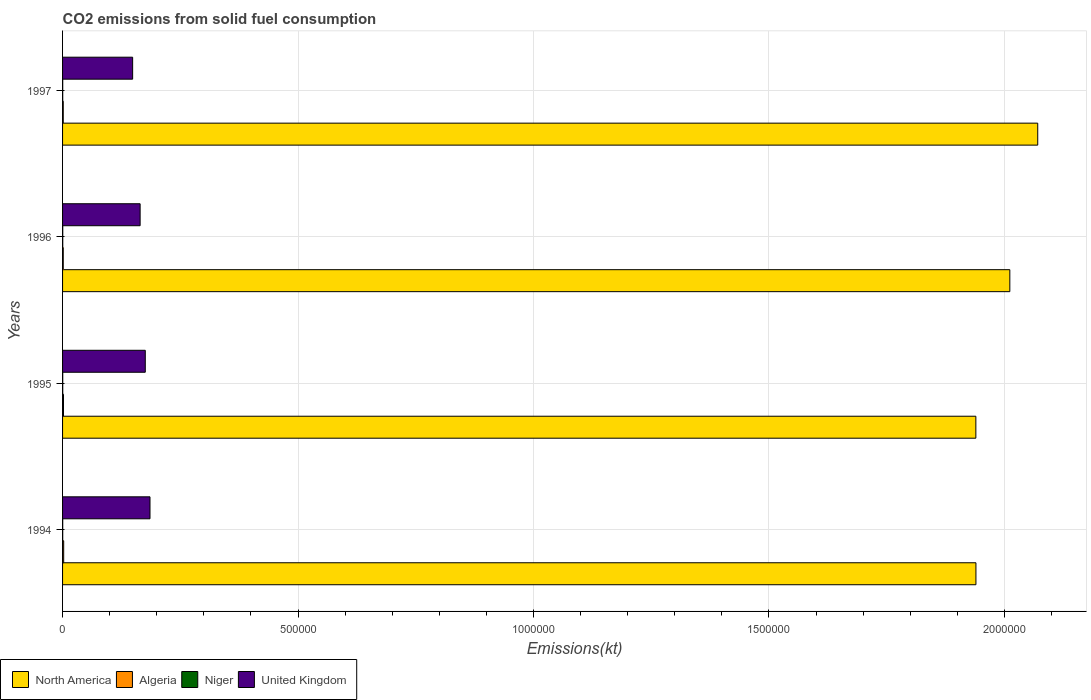How many different coloured bars are there?
Your answer should be very brief. 4. How many bars are there on the 3rd tick from the top?
Make the answer very short. 4. In how many cases, is the number of bars for a given year not equal to the number of legend labels?
Offer a very short reply. 0. What is the amount of CO2 emitted in United Kingdom in 1994?
Make the answer very short. 1.86e+05. Across all years, what is the maximum amount of CO2 emitted in United Kingdom?
Offer a terse response. 1.86e+05. Across all years, what is the minimum amount of CO2 emitted in North America?
Your response must be concise. 1.94e+06. In which year was the amount of CO2 emitted in Algeria minimum?
Offer a terse response. 1997. What is the total amount of CO2 emitted in Niger in the graph?
Give a very brief answer. 1400.79. What is the difference between the amount of CO2 emitted in Niger in 1994 and that in 1995?
Your answer should be compact. -29.34. What is the difference between the amount of CO2 emitted in North America in 1994 and the amount of CO2 emitted in Algeria in 1995?
Give a very brief answer. 1.94e+06. What is the average amount of CO2 emitted in North America per year?
Ensure brevity in your answer.  1.99e+06. In the year 1995, what is the difference between the amount of CO2 emitted in Algeria and amount of CO2 emitted in United Kingdom?
Make the answer very short. -1.74e+05. What is the ratio of the amount of CO2 emitted in United Kingdom in 1994 to that in 1995?
Keep it short and to the point. 1.06. What is the difference between the highest and the second highest amount of CO2 emitted in Niger?
Keep it short and to the point. 22. What is the difference between the highest and the lowest amount of CO2 emitted in Algeria?
Give a very brief answer. 931.42. In how many years, is the amount of CO2 emitted in Algeria greater than the average amount of CO2 emitted in Algeria taken over all years?
Give a very brief answer. 2. Is the sum of the amount of CO2 emitted in Algeria in 1995 and 1996 greater than the maximum amount of CO2 emitted in Niger across all years?
Your answer should be compact. Yes. What does the 2nd bar from the bottom in 1994 represents?
Offer a very short reply. Algeria. How many bars are there?
Ensure brevity in your answer.  16. Are all the bars in the graph horizontal?
Give a very brief answer. Yes. Are the values on the major ticks of X-axis written in scientific E-notation?
Keep it short and to the point. No. Does the graph contain any zero values?
Give a very brief answer. No. Does the graph contain grids?
Keep it short and to the point. Yes. Where does the legend appear in the graph?
Make the answer very short. Bottom left. How are the legend labels stacked?
Keep it short and to the point. Horizontal. What is the title of the graph?
Your answer should be very brief. CO2 emissions from solid fuel consumption. Does "El Salvador" appear as one of the legend labels in the graph?
Keep it short and to the point. No. What is the label or title of the X-axis?
Your answer should be compact. Emissions(kt). What is the label or title of the Y-axis?
Offer a very short reply. Years. What is the Emissions(kt) of North America in 1994?
Offer a terse response. 1.94e+06. What is the Emissions(kt) in Algeria in 1994?
Your answer should be very brief. 2368.88. What is the Emissions(kt) in Niger in 1994?
Ensure brevity in your answer.  326.36. What is the Emissions(kt) of United Kingdom in 1994?
Offer a terse response. 1.86e+05. What is the Emissions(kt) in North America in 1995?
Your answer should be very brief. 1.94e+06. What is the Emissions(kt) in Algeria in 1995?
Offer a terse response. 1987.51. What is the Emissions(kt) in Niger in 1995?
Provide a succinct answer. 355.7. What is the Emissions(kt) in United Kingdom in 1995?
Give a very brief answer. 1.76e+05. What is the Emissions(kt) of North America in 1996?
Ensure brevity in your answer.  2.01e+06. What is the Emissions(kt) of Algeria in 1996?
Offer a terse response. 1441.13. What is the Emissions(kt) in Niger in 1996?
Offer a very short reply. 377.7. What is the Emissions(kt) in United Kingdom in 1996?
Your response must be concise. 1.65e+05. What is the Emissions(kt) in North America in 1997?
Provide a succinct answer. 2.07e+06. What is the Emissions(kt) of Algeria in 1997?
Keep it short and to the point. 1437.46. What is the Emissions(kt) of Niger in 1997?
Keep it short and to the point. 341.03. What is the Emissions(kt) of United Kingdom in 1997?
Offer a terse response. 1.49e+05. Across all years, what is the maximum Emissions(kt) of North America?
Make the answer very short. 2.07e+06. Across all years, what is the maximum Emissions(kt) of Algeria?
Offer a terse response. 2368.88. Across all years, what is the maximum Emissions(kt) of Niger?
Offer a terse response. 377.7. Across all years, what is the maximum Emissions(kt) in United Kingdom?
Make the answer very short. 1.86e+05. Across all years, what is the minimum Emissions(kt) in North America?
Provide a succinct answer. 1.94e+06. Across all years, what is the minimum Emissions(kt) of Algeria?
Offer a terse response. 1437.46. Across all years, what is the minimum Emissions(kt) in Niger?
Your answer should be compact. 326.36. Across all years, what is the minimum Emissions(kt) in United Kingdom?
Your answer should be compact. 1.49e+05. What is the total Emissions(kt) of North America in the graph?
Give a very brief answer. 7.96e+06. What is the total Emissions(kt) in Algeria in the graph?
Offer a terse response. 7234.99. What is the total Emissions(kt) in Niger in the graph?
Your answer should be compact. 1400.79. What is the total Emissions(kt) of United Kingdom in the graph?
Your answer should be compact. 6.75e+05. What is the difference between the Emissions(kt) in North America in 1994 and that in 1995?
Keep it short and to the point. 176.09. What is the difference between the Emissions(kt) in Algeria in 1994 and that in 1995?
Give a very brief answer. 381.37. What is the difference between the Emissions(kt) of Niger in 1994 and that in 1995?
Offer a very short reply. -29.34. What is the difference between the Emissions(kt) in United Kingdom in 1994 and that in 1995?
Your answer should be compact. 1.00e+04. What is the difference between the Emissions(kt) in North America in 1994 and that in 1996?
Provide a short and direct response. -7.20e+04. What is the difference between the Emissions(kt) in Algeria in 1994 and that in 1996?
Offer a very short reply. 927.75. What is the difference between the Emissions(kt) of Niger in 1994 and that in 1996?
Make the answer very short. -51.34. What is the difference between the Emissions(kt) in United Kingdom in 1994 and that in 1996?
Make the answer very short. 2.09e+04. What is the difference between the Emissions(kt) in North America in 1994 and that in 1997?
Your answer should be compact. -1.31e+05. What is the difference between the Emissions(kt) of Algeria in 1994 and that in 1997?
Keep it short and to the point. 931.42. What is the difference between the Emissions(kt) of Niger in 1994 and that in 1997?
Your response must be concise. -14.67. What is the difference between the Emissions(kt) of United Kingdom in 1994 and that in 1997?
Provide a succinct answer. 3.68e+04. What is the difference between the Emissions(kt) in North America in 1995 and that in 1996?
Your answer should be compact. -7.21e+04. What is the difference between the Emissions(kt) in Algeria in 1995 and that in 1996?
Ensure brevity in your answer.  546.38. What is the difference between the Emissions(kt) in Niger in 1995 and that in 1996?
Your answer should be compact. -22. What is the difference between the Emissions(kt) in United Kingdom in 1995 and that in 1996?
Give a very brief answer. 1.09e+04. What is the difference between the Emissions(kt) in North America in 1995 and that in 1997?
Provide a short and direct response. -1.31e+05. What is the difference between the Emissions(kt) of Algeria in 1995 and that in 1997?
Your answer should be compact. 550.05. What is the difference between the Emissions(kt) of Niger in 1995 and that in 1997?
Give a very brief answer. 14.67. What is the difference between the Emissions(kt) in United Kingdom in 1995 and that in 1997?
Provide a succinct answer. 2.68e+04. What is the difference between the Emissions(kt) in North America in 1996 and that in 1997?
Offer a very short reply. -5.93e+04. What is the difference between the Emissions(kt) in Algeria in 1996 and that in 1997?
Offer a terse response. 3.67. What is the difference between the Emissions(kt) of Niger in 1996 and that in 1997?
Keep it short and to the point. 36.67. What is the difference between the Emissions(kt) of United Kingdom in 1996 and that in 1997?
Give a very brief answer. 1.59e+04. What is the difference between the Emissions(kt) of North America in 1994 and the Emissions(kt) of Algeria in 1995?
Make the answer very short. 1.94e+06. What is the difference between the Emissions(kt) in North America in 1994 and the Emissions(kt) in Niger in 1995?
Your answer should be very brief. 1.94e+06. What is the difference between the Emissions(kt) of North America in 1994 and the Emissions(kt) of United Kingdom in 1995?
Give a very brief answer. 1.76e+06. What is the difference between the Emissions(kt) of Algeria in 1994 and the Emissions(kt) of Niger in 1995?
Provide a short and direct response. 2013.18. What is the difference between the Emissions(kt) of Algeria in 1994 and the Emissions(kt) of United Kingdom in 1995?
Make the answer very short. -1.73e+05. What is the difference between the Emissions(kt) of Niger in 1994 and the Emissions(kt) of United Kingdom in 1995?
Keep it short and to the point. -1.75e+05. What is the difference between the Emissions(kt) of North America in 1994 and the Emissions(kt) of Algeria in 1996?
Offer a terse response. 1.94e+06. What is the difference between the Emissions(kt) of North America in 1994 and the Emissions(kt) of Niger in 1996?
Offer a terse response. 1.94e+06. What is the difference between the Emissions(kt) of North America in 1994 and the Emissions(kt) of United Kingdom in 1996?
Your response must be concise. 1.77e+06. What is the difference between the Emissions(kt) in Algeria in 1994 and the Emissions(kt) in Niger in 1996?
Provide a succinct answer. 1991.18. What is the difference between the Emissions(kt) of Algeria in 1994 and the Emissions(kt) of United Kingdom in 1996?
Make the answer very short. -1.62e+05. What is the difference between the Emissions(kt) of Niger in 1994 and the Emissions(kt) of United Kingdom in 1996?
Offer a very short reply. -1.64e+05. What is the difference between the Emissions(kt) in North America in 1994 and the Emissions(kt) in Algeria in 1997?
Make the answer very short. 1.94e+06. What is the difference between the Emissions(kt) in North America in 1994 and the Emissions(kt) in Niger in 1997?
Provide a succinct answer. 1.94e+06. What is the difference between the Emissions(kt) of North America in 1994 and the Emissions(kt) of United Kingdom in 1997?
Make the answer very short. 1.79e+06. What is the difference between the Emissions(kt) in Algeria in 1994 and the Emissions(kt) in Niger in 1997?
Your response must be concise. 2027.85. What is the difference between the Emissions(kt) in Algeria in 1994 and the Emissions(kt) in United Kingdom in 1997?
Ensure brevity in your answer.  -1.46e+05. What is the difference between the Emissions(kt) in Niger in 1994 and the Emissions(kt) in United Kingdom in 1997?
Offer a terse response. -1.48e+05. What is the difference between the Emissions(kt) in North America in 1995 and the Emissions(kt) in Algeria in 1996?
Give a very brief answer. 1.94e+06. What is the difference between the Emissions(kt) in North America in 1995 and the Emissions(kt) in Niger in 1996?
Keep it short and to the point. 1.94e+06. What is the difference between the Emissions(kt) of North America in 1995 and the Emissions(kt) of United Kingdom in 1996?
Give a very brief answer. 1.77e+06. What is the difference between the Emissions(kt) in Algeria in 1995 and the Emissions(kt) in Niger in 1996?
Your answer should be very brief. 1609.81. What is the difference between the Emissions(kt) of Algeria in 1995 and the Emissions(kt) of United Kingdom in 1996?
Your answer should be very brief. -1.63e+05. What is the difference between the Emissions(kt) of Niger in 1995 and the Emissions(kt) of United Kingdom in 1996?
Your answer should be compact. -1.64e+05. What is the difference between the Emissions(kt) of North America in 1995 and the Emissions(kt) of Algeria in 1997?
Keep it short and to the point. 1.94e+06. What is the difference between the Emissions(kt) in North America in 1995 and the Emissions(kt) in Niger in 1997?
Give a very brief answer. 1.94e+06. What is the difference between the Emissions(kt) in North America in 1995 and the Emissions(kt) in United Kingdom in 1997?
Provide a succinct answer. 1.79e+06. What is the difference between the Emissions(kt) in Algeria in 1995 and the Emissions(kt) in Niger in 1997?
Offer a very short reply. 1646.48. What is the difference between the Emissions(kt) in Algeria in 1995 and the Emissions(kt) in United Kingdom in 1997?
Provide a short and direct response. -1.47e+05. What is the difference between the Emissions(kt) in Niger in 1995 and the Emissions(kt) in United Kingdom in 1997?
Provide a short and direct response. -1.48e+05. What is the difference between the Emissions(kt) in North America in 1996 and the Emissions(kt) in Algeria in 1997?
Your answer should be very brief. 2.01e+06. What is the difference between the Emissions(kt) of North America in 1996 and the Emissions(kt) of Niger in 1997?
Ensure brevity in your answer.  2.01e+06. What is the difference between the Emissions(kt) of North America in 1996 and the Emissions(kt) of United Kingdom in 1997?
Give a very brief answer. 1.86e+06. What is the difference between the Emissions(kt) in Algeria in 1996 and the Emissions(kt) in Niger in 1997?
Keep it short and to the point. 1100.1. What is the difference between the Emissions(kt) in Algeria in 1996 and the Emissions(kt) in United Kingdom in 1997?
Keep it short and to the point. -1.47e+05. What is the difference between the Emissions(kt) in Niger in 1996 and the Emissions(kt) in United Kingdom in 1997?
Make the answer very short. -1.48e+05. What is the average Emissions(kt) of North America per year?
Your response must be concise. 1.99e+06. What is the average Emissions(kt) in Algeria per year?
Make the answer very short. 1808.75. What is the average Emissions(kt) of Niger per year?
Keep it short and to the point. 350.2. What is the average Emissions(kt) in United Kingdom per year?
Provide a short and direct response. 1.69e+05. In the year 1994, what is the difference between the Emissions(kt) of North America and Emissions(kt) of Algeria?
Provide a succinct answer. 1.94e+06. In the year 1994, what is the difference between the Emissions(kt) in North America and Emissions(kt) in Niger?
Your answer should be compact. 1.94e+06. In the year 1994, what is the difference between the Emissions(kt) in North America and Emissions(kt) in United Kingdom?
Provide a short and direct response. 1.75e+06. In the year 1994, what is the difference between the Emissions(kt) of Algeria and Emissions(kt) of Niger?
Make the answer very short. 2042.52. In the year 1994, what is the difference between the Emissions(kt) in Algeria and Emissions(kt) in United Kingdom?
Provide a succinct answer. -1.83e+05. In the year 1994, what is the difference between the Emissions(kt) of Niger and Emissions(kt) of United Kingdom?
Ensure brevity in your answer.  -1.85e+05. In the year 1995, what is the difference between the Emissions(kt) in North America and Emissions(kt) in Algeria?
Offer a very short reply. 1.94e+06. In the year 1995, what is the difference between the Emissions(kt) of North America and Emissions(kt) of Niger?
Your response must be concise. 1.94e+06. In the year 1995, what is the difference between the Emissions(kt) in North America and Emissions(kt) in United Kingdom?
Your response must be concise. 1.76e+06. In the year 1995, what is the difference between the Emissions(kt) in Algeria and Emissions(kt) in Niger?
Offer a very short reply. 1631.82. In the year 1995, what is the difference between the Emissions(kt) in Algeria and Emissions(kt) in United Kingdom?
Your response must be concise. -1.74e+05. In the year 1995, what is the difference between the Emissions(kt) in Niger and Emissions(kt) in United Kingdom?
Keep it short and to the point. -1.75e+05. In the year 1996, what is the difference between the Emissions(kt) of North America and Emissions(kt) of Algeria?
Your answer should be very brief. 2.01e+06. In the year 1996, what is the difference between the Emissions(kt) of North America and Emissions(kt) of Niger?
Provide a short and direct response. 2.01e+06. In the year 1996, what is the difference between the Emissions(kt) in North America and Emissions(kt) in United Kingdom?
Give a very brief answer. 1.85e+06. In the year 1996, what is the difference between the Emissions(kt) of Algeria and Emissions(kt) of Niger?
Your answer should be compact. 1063.43. In the year 1996, what is the difference between the Emissions(kt) in Algeria and Emissions(kt) in United Kingdom?
Your response must be concise. -1.63e+05. In the year 1996, what is the difference between the Emissions(kt) of Niger and Emissions(kt) of United Kingdom?
Provide a succinct answer. -1.64e+05. In the year 1997, what is the difference between the Emissions(kt) in North America and Emissions(kt) in Algeria?
Give a very brief answer. 2.07e+06. In the year 1997, what is the difference between the Emissions(kt) of North America and Emissions(kt) of Niger?
Keep it short and to the point. 2.07e+06. In the year 1997, what is the difference between the Emissions(kt) in North America and Emissions(kt) in United Kingdom?
Provide a short and direct response. 1.92e+06. In the year 1997, what is the difference between the Emissions(kt) in Algeria and Emissions(kt) in Niger?
Keep it short and to the point. 1096.43. In the year 1997, what is the difference between the Emissions(kt) in Algeria and Emissions(kt) in United Kingdom?
Give a very brief answer. -1.47e+05. In the year 1997, what is the difference between the Emissions(kt) of Niger and Emissions(kt) of United Kingdom?
Provide a short and direct response. -1.48e+05. What is the ratio of the Emissions(kt) in Algeria in 1994 to that in 1995?
Offer a very short reply. 1.19. What is the ratio of the Emissions(kt) in Niger in 1994 to that in 1995?
Provide a short and direct response. 0.92. What is the ratio of the Emissions(kt) in United Kingdom in 1994 to that in 1995?
Your response must be concise. 1.06. What is the ratio of the Emissions(kt) of North America in 1994 to that in 1996?
Your answer should be compact. 0.96. What is the ratio of the Emissions(kt) of Algeria in 1994 to that in 1996?
Your response must be concise. 1.64. What is the ratio of the Emissions(kt) in Niger in 1994 to that in 1996?
Ensure brevity in your answer.  0.86. What is the ratio of the Emissions(kt) of United Kingdom in 1994 to that in 1996?
Your response must be concise. 1.13. What is the ratio of the Emissions(kt) of North America in 1994 to that in 1997?
Make the answer very short. 0.94. What is the ratio of the Emissions(kt) of Algeria in 1994 to that in 1997?
Offer a terse response. 1.65. What is the ratio of the Emissions(kt) in Niger in 1994 to that in 1997?
Provide a short and direct response. 0.96. What is the ratio of the Emissions(kt) of United Kingdom in 1994 to that in 1997?
Give a very brief answer. 1.25. What is the ratio of the Emissions(kt) in North America in 1995 to that in 1996?
Make the answer very short. 0.96. What is the ratio of the Emissions(kt) in Algeria in 1995 to that in 1996?
Your response must be concise. 1.38. What is the ratio of the Emissions(kt) in Niger in 1995 to that in 1996?
Keep it short and to the point. 0.94. What is the ratio of the Emissions(kt) of United Kingdom in 1995 to that in 1996?
Offer a very short reply. 1.07. What is the ratio of the Emissions(kt) of North America in 1995 to that in 1997?
Give a very brief answer. 0.94. What is the ratio of the Emissions(kt) of Algeria in 1995 to that in 1997?
Your answer should be compact. 1.38. What is the ratio of the Emissions(kt) in Niger in 1995 to that in 1997?
Make the answer very short. 1.04. What is the ratio of the Emissions(kt) in United Kingdom in 1995 to that in 1997?
Give a very brief answer. 1.18. What is the ratio of the Emissions(kt) in North America in 1996 to that in 1997?
Provide a short and direct response. 0.97. What is the ratio of the Emissions(kt) of Niger in 1996 to that in 1997?
Offer a terse response. 1.11. What is the ratio of the Emissions(kt) in United Kingdom in 1996 to that in 1997?
Your answer should be very brief. 1.11. What is the difference between the highest and the second highest Emissions(kt) of North America?
Your response must be concise. 5.93e+04. What is the difference between the highest and the second highest Emissions(kt) of Algeria?
Your response must be concise. 381.37. What is the difference between the highest and the second highest Emissions(kt) of Niger?
Give a very brief answer. 22. What is the difference between the highest and the second highest Emissions(kt) of United Kingdom?
Ensure brevity in your answer.  1.00e+04. What is the difference between the highest and the lowest Emissions(kt) in North America?
Your answer should be very brief. 1.31e+05. What is the difference between the highest and the lowest Emissions(kt) in Algeria?
Give a very brief answer. 931.42. What is the difference between the highest and the lowest Emissions(kt) in Niger?
Keep it short and to the point. 51.34. What is the difference between the highest and the lowest Emissions(kt) in United Kingdom?
Your response must be concise. 3.68e+04. 